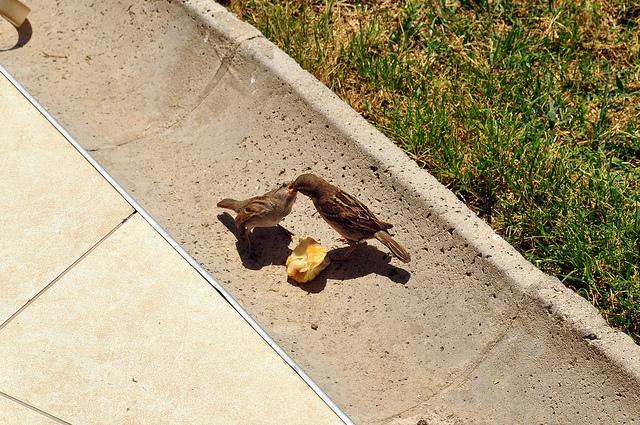How many birds are there?
Quick response, please. 2. Are the birds eating?
Keep it brief. Yes. What is the curved cement structure that the birds are in?
Be succinct. Gutter. 